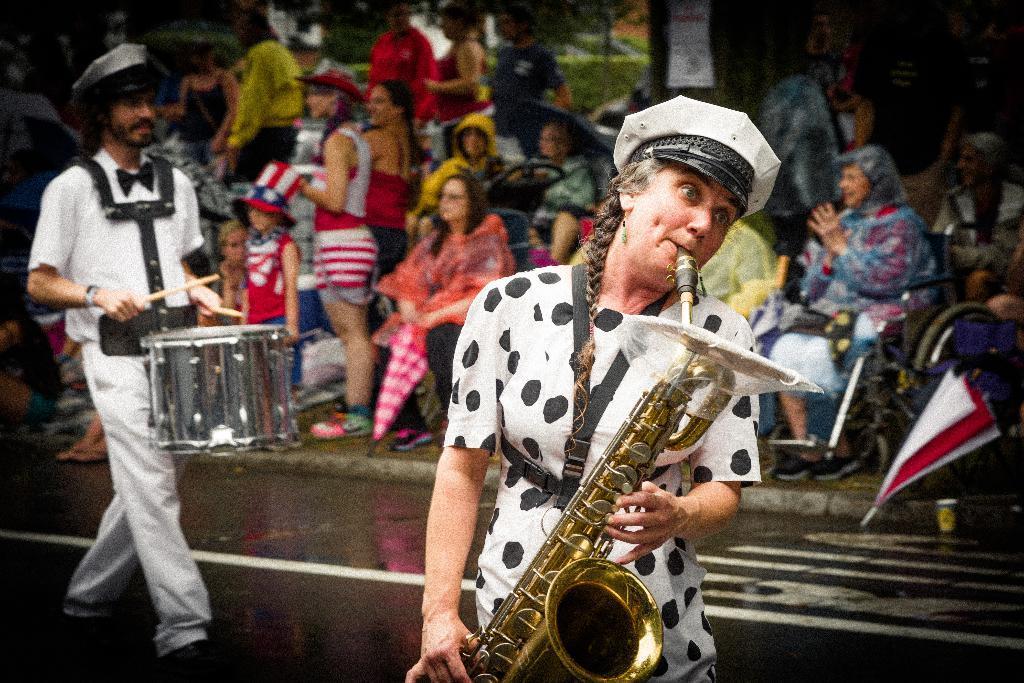How would you summarize this image in a sentence or two? This picture shows a group of people seated on the chairs couple of them holding umbrellas in their hands and we see two people performing with musical instruments one is holding side drums and one is holding saxophone 